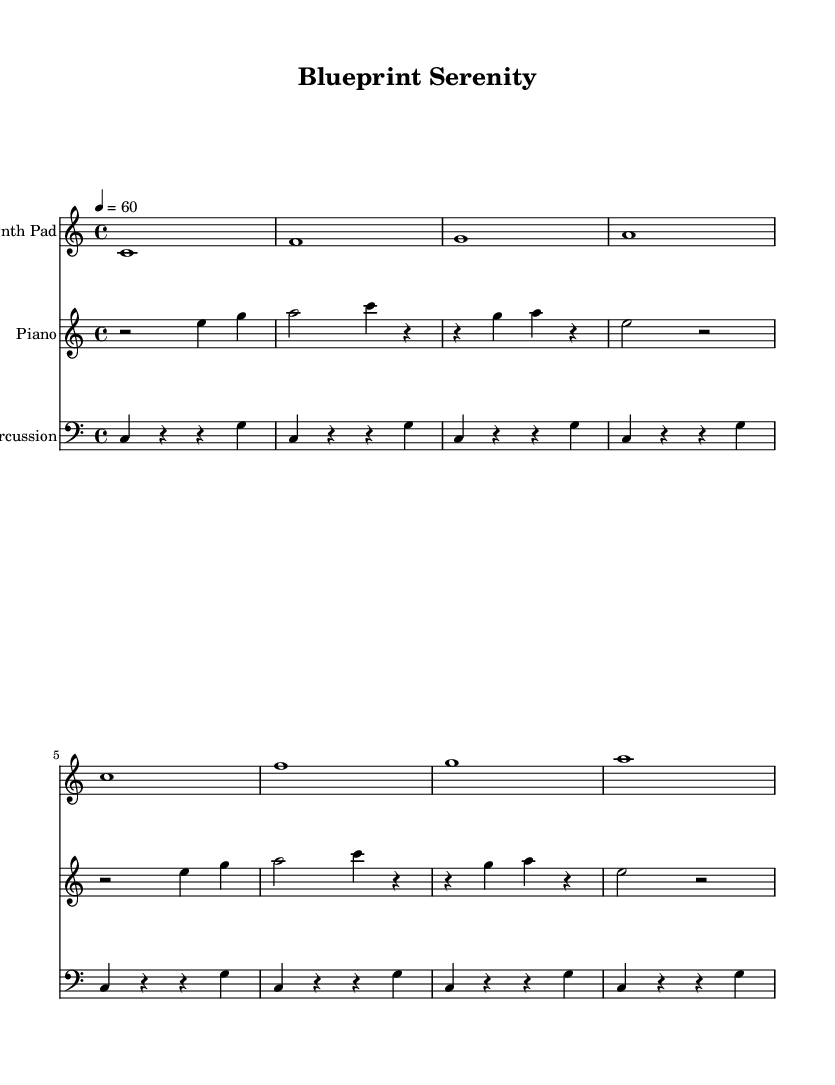What is the key signature of this music? The key signature is C major, which has no sharps or flats.
Answer: C major What is the time signature of this music? The time signature is indicated at the beginning of the piece, showing that there are four beats per measure.
Answer: 4/4 What is the tempo marking? The tempo marking is indicated at the start of the piece, specifying a quarter note equals sixty beats per minute.
Answer: 60 How many measures are in the music? Counting the measures from the sheet music, there are a total of eight measures throughout the piece.
Answer: 8 What instrument is listed as the first staff? The first staff is labeled "Synth Pad", showing which instrument is used for that particular set of notes.
Answer: Synth Pad Which instrument has the clef set as treble? Both the "Synth Pad" and "Piano" staves are using the treble clef, which is suitable for higher-pitched notes.
Answer: Synth Pad, Piano What type of music is represented here? The music features ambient electronic soundscapes characterized by synthetic and piano textures suitable for focus and relaxation.
Answer: Electronic 